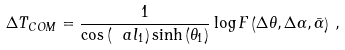<formula> <loc_0><loc_0><loc_500><loc_500>\Delta T _ { C O M } = \frac { 1 } { \cos \left ( \ a l _ { 1 } \right ) \sinh \left ( \theta _ { 1 } \right ) } \log F \left ( \Delta \theta , \Delta \alpha , \bar { \alpha } \right ) \, ,</formula> 